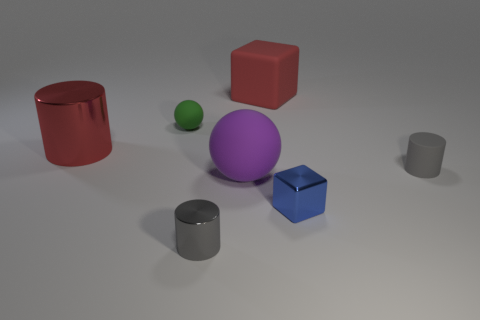What number of other objects are there of the same shape as the tiny gray metallic thing?
Give a very brief answer. 2. What size is the red object to the left of the large red thing right of the big object left of the tiny green object?
Offer a very short reply. Large. How many brown objects are either rubber blocks or small balls?
Your response must be concise. 0. The green matte thing that is behind the tiny gray cylinder on the left side of the tiny blue cube is what shape?
Offer a terse response. Sphere. There is a sphere that is on the right side of the gray shiny thing; is its size the same as the matte ball behind the large red shiny cylinder?
Give a very brief answer. No. Are there any big purple blocks made of the same material as the purple sphere?
Make the answer very short. No. What size is the cylinder that is the same color as the matte block?
Your answer should be compact. Large. Are there any purple spheres behind the large rubber object behind the sphere that is behind the red metallic thing?
Offer a terse response. No. Are there any small gray rubber objects left of the small blue metal cube?
Offer a very short reply. No. How many small cubes are on the right side of the tiny gray cylinder to the left of the matte cylinder?
Your answer should be compact. 1. 